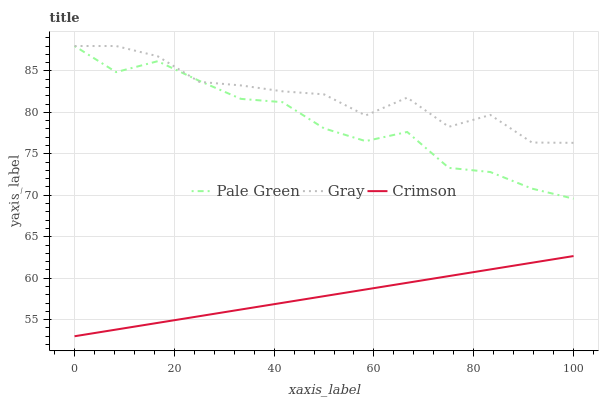Does Crimson have the minimum area under the curve?
Answer yes or no. Yes. Does Gray have the maximum area under the curve?
Answer yes or no. Yes. Does Pale Green have the minimum area under the curve?
Answer yes or no. No. Does Pale Green have the maximum area under the curve?
Answer yes or no. No. Is Crimson the smoothest?
Answer yes or no. Yes. Is Gray the roughest?
Answer yes or no. Yes. Is Pale Green the smoothest?
Answer yes or no. No. Is Pale Green the roughest?
Answer yes or no. No. Does Crimson have the lowest value?
Answer yes or no. Yes. Does Pale Green have the lowest value?
Answer yes or no. No. Does Pale Green have the highest value?
Answer yes or no. Yes. Is Crimson less than Gray?
Answer yes or no. Yes. Is Gray greater than Crimson?
Answer yes or no. Yes. Does Pale Green intersect Gray?
Answer yes or no. Yes. Is Pale Green less than Gray?
Answer yes or no. No. Is Pale Green greater than Gray?
Answer yes or no. No. Does Crimson intersect Gray?
Answer yes or no. No. 